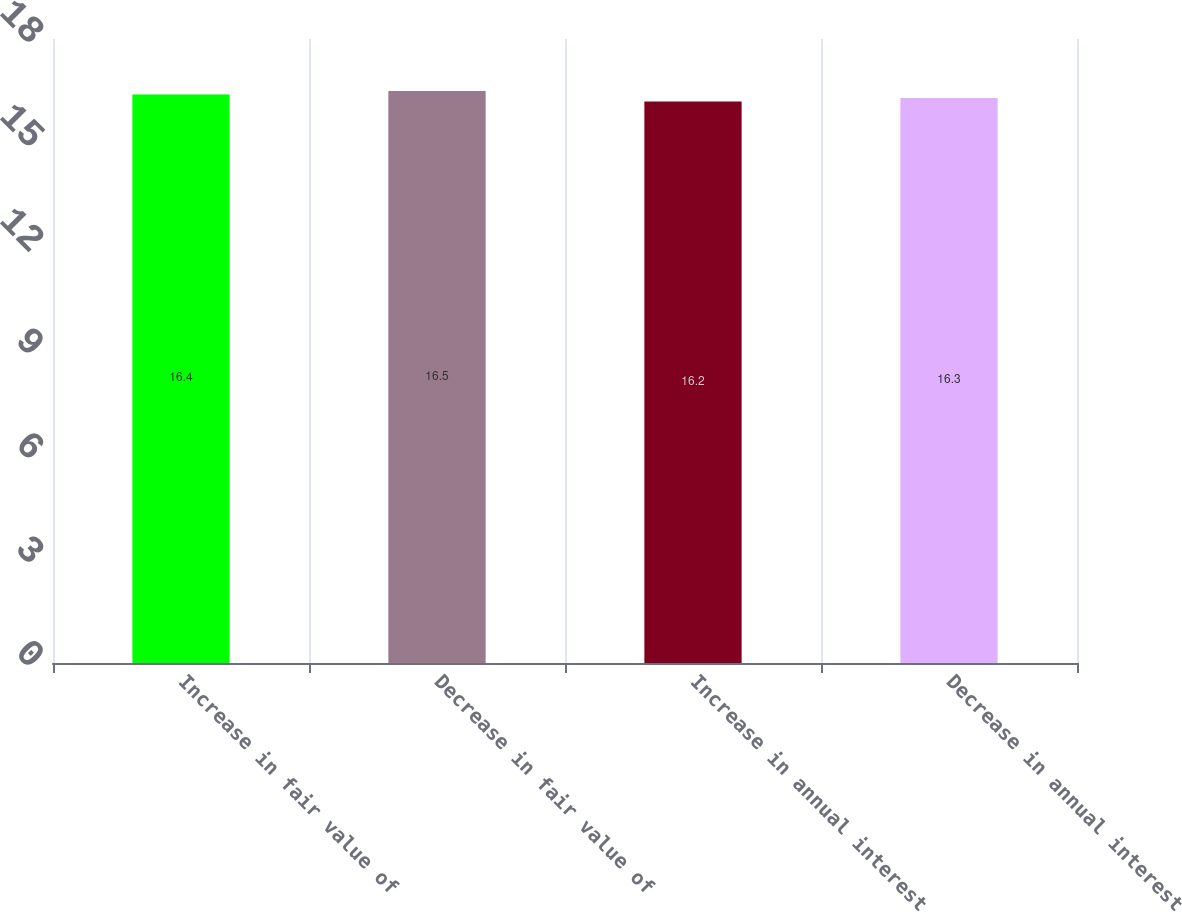Convert chart. <chart><loc_0><loc_0><loc_500><loc_500><bar_chart><fcel>Increase in fair value of<fcel>Decrease in fair value of<fcel>Increase in annual interest<fcel>Decrease in annual interest<nl><fcel>16.4<fcel>16.5<fcel>16.2<fcel>16.3<nl></chart> 